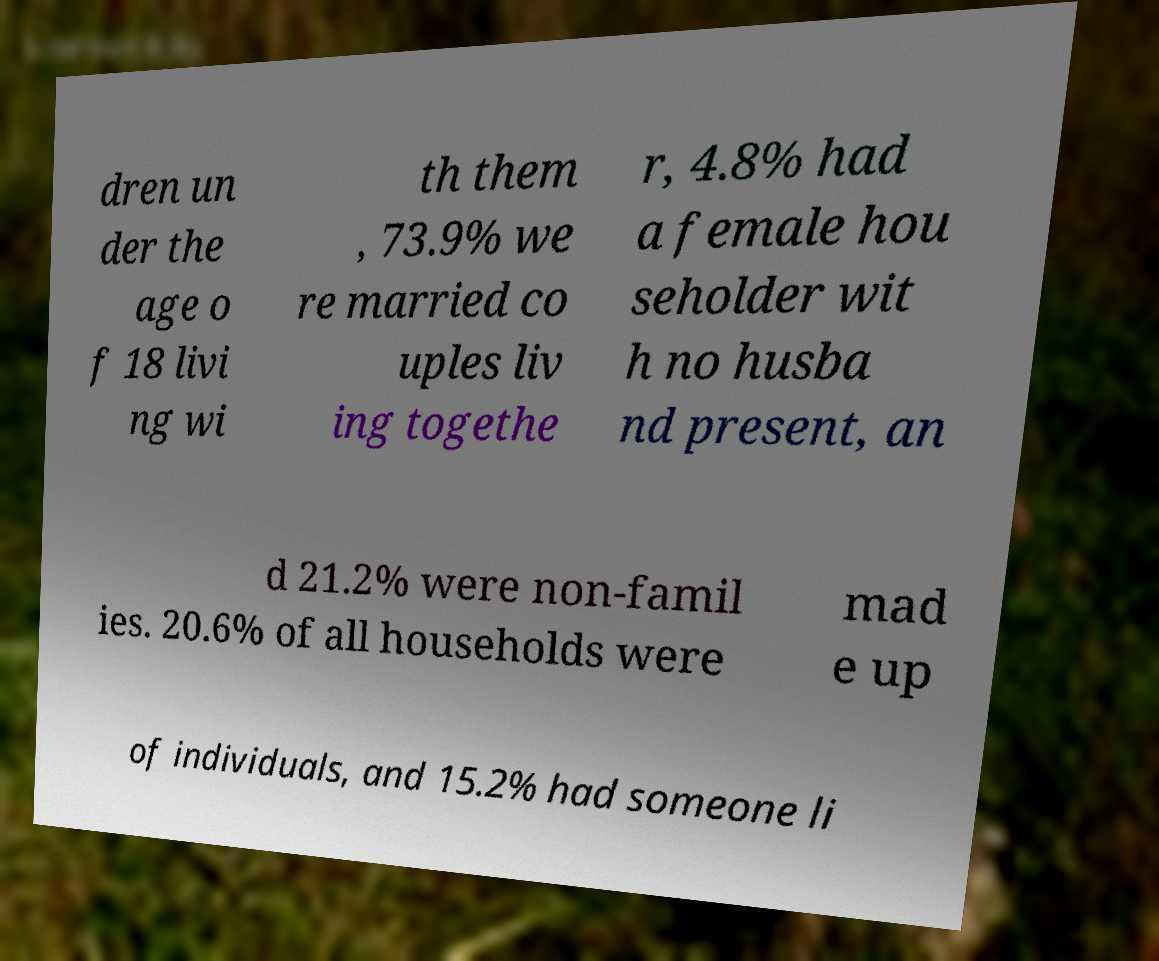Could you extract and type out the text from this image? dren un der the age o f 18 livi ng wi th them , 73.9% we re married co uples liv ing togethe r, 4.8% had a female hou seholder wit h no husba nd present, an d 21.2% were non-famil ies. 20.6% of all households were mad e up of individuals, and 15.2% had someone li 